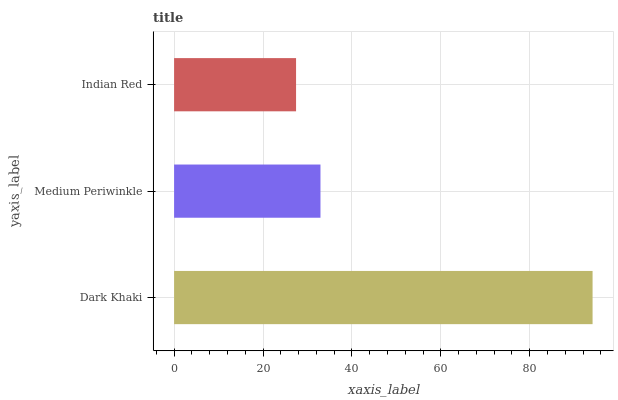Is Indian Red the minimum?
Answer yes or no. Yes. Is Dark Khaki the maximum?
Answer yes or no. Yes. Is Medium Periwinkle the minimum?
Answer yes or no. No. Is Medium Periwinkle the maximum?
Answer yes or no. No. Is Dark Khaki greater than Medium Periwinkle?
Answer yes or no. Yes. Is Medium Periwinkle less than Dark Khaki?
Answer yes or no. Yes. Is Medium Periwinkle greater than Dark Khaki?
Answer yes or no. No. Is Dark Khaki less than Medium Periwinkle?
Answer yes or no. No. Is Medium Periwinkle the high median?
Answer yes or no. Yes. Is Medium Periwinkle the low median?
Answer yes or no. Yes. Is Indian Red the high median?
Answer yes or no. No. Is Dark Khaki the low median?
Answer yes or no. No. 